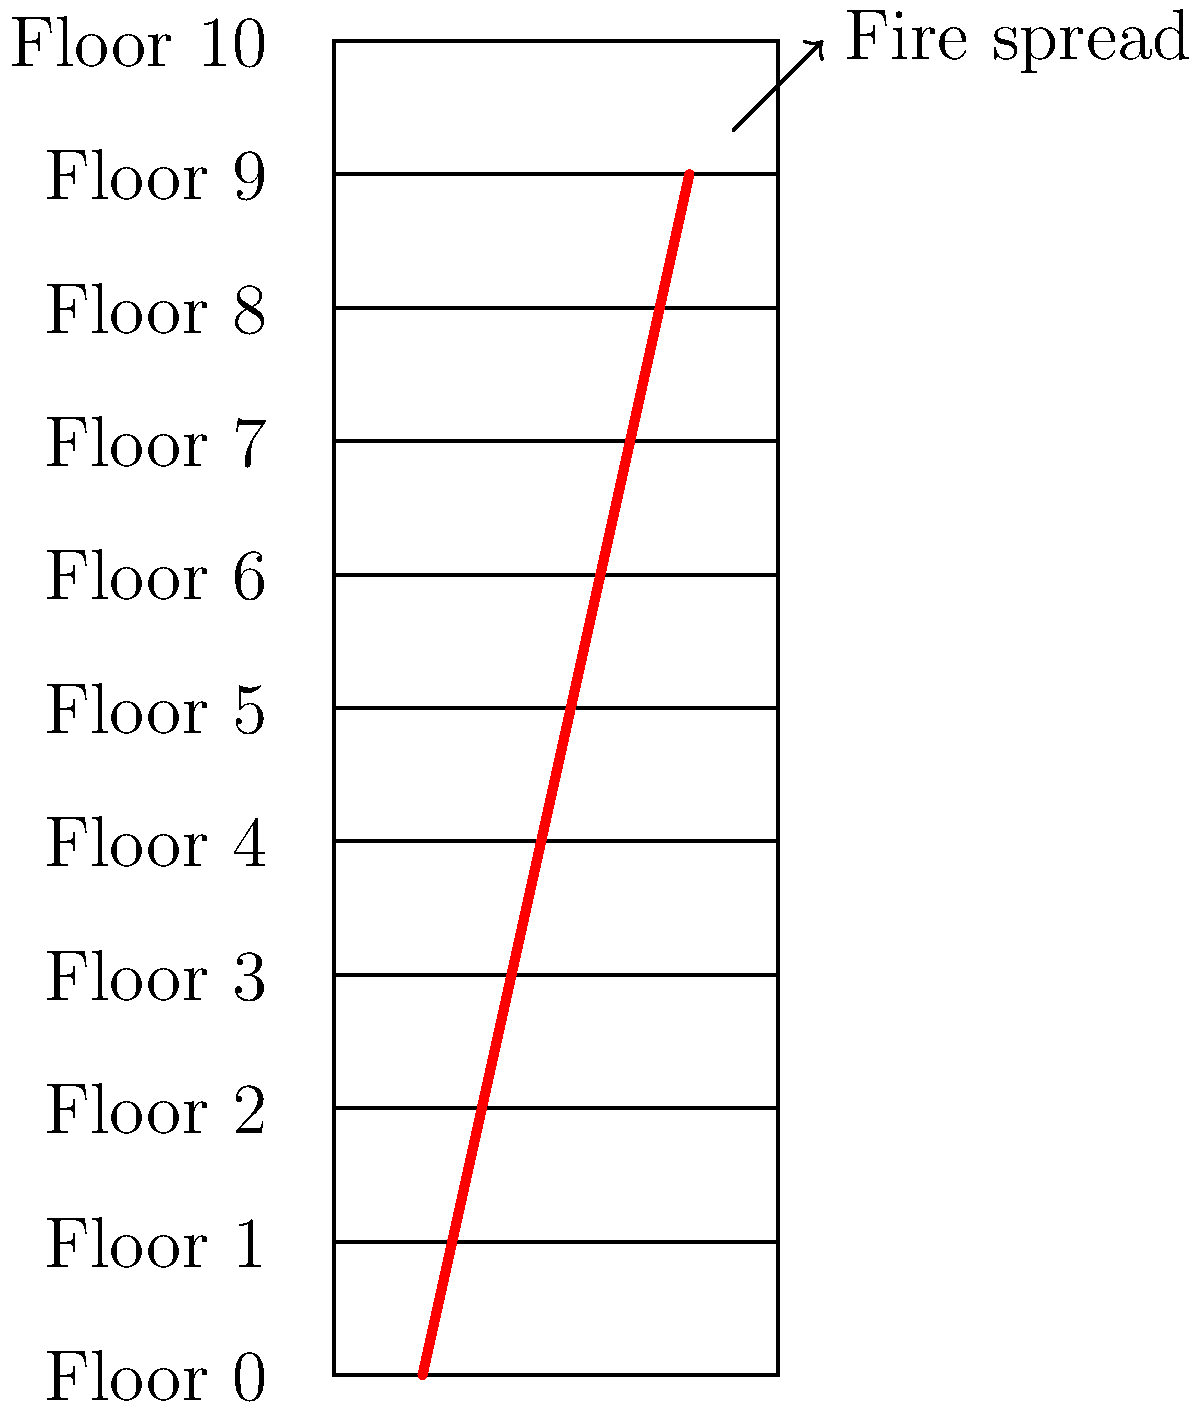Based on the cross-sectional diagram of Grenfell Tower, which shows the spread of fire from the lower floors to the upper floors, estimate how many floors the fire spread through in approximately 2 hours if it took about 15 minutes to spread through each floor? To solve this problem, we need to follow these steps:

1. Understand the given information:
   - The fire spreads from lower to upper floors
   - It takes about 15 minutes to spread through each floor
   - We want to know how many floors it spreads through in 2 hours

2. Convert 2 hours to minutes:
   $2 \text{ hours} = 2 \times 60 \text{ minutes} = 120 \text{ minutes}$

3. Calculate how many 15-minute intervals are in 120 minutes:
   $\frac{120 \text{ minutes}}{15 \text{ minutes per floor}} = 8$

4. Therefore, in 2 hours (120 minutes), the fire would spread through approximately 8 floors.

5. Verify this with the diagram:
   The fire path shown in red spans about 8-9 floor levels, which aligns with our calculation.
Answer: 8 floors 